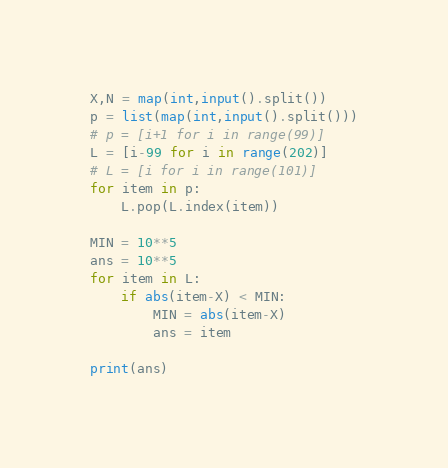Convert code to text. <code><loc_0><loc_0><loc_500><loc_500><_Python_>X,N = map(int,input().split())
p = list(map(int,input().split()))
# p = [i+1 for i in range(99)]
L = [i-99 for i in range(202)]
# L = [i for i in range(101)]
for item in p:
    L.pop(L.index(item))
 
MIN = 10**5
ans = 10**5
for item in L:
    if abs(item-X) < MIN:
        MIN = abs(item-X)
        ans = item
 
print(ans)</code> 